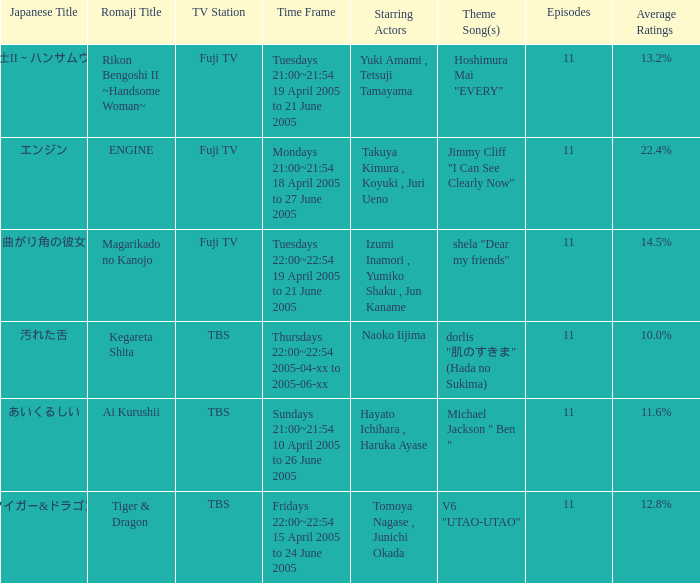6%? あいくるしい. 